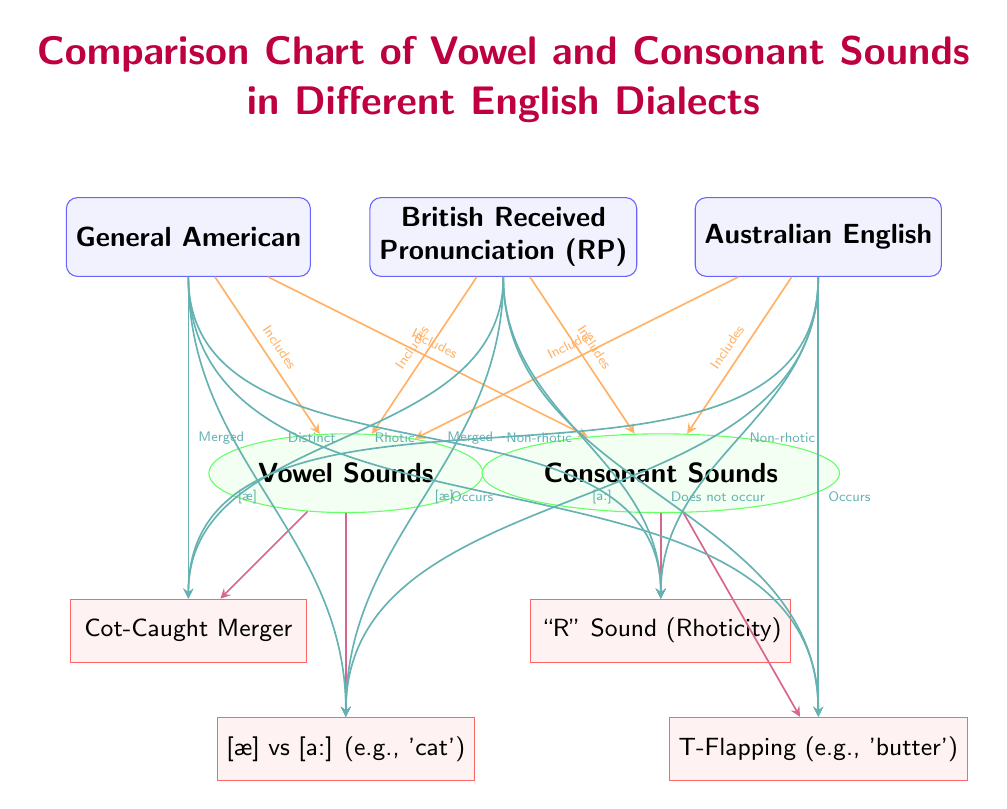What dialects are compared in the chart? The chart compares three dialects: General American, British Received Pronunciation (RP), and Australian English. These are the main nodes that represent the different dialects, making it easy to identify them at the top of the diagram.
Answer: General American, British Received Pronunciation, Australian English How many categories of sounds are included in the chart? The chart differentiates sounds into two main categories: Vowel Sounds and Consonant Sounds. This distinction is evident from the two category nodes positioned below the dialects.
Answer: 2 Which dialect shows a distinct Cot-Caught Merger? The British Received Pronunciation (RP) dialect is indicated to have a distinct Cot-Caught Merger, highlighted in the feature connections where the edge leads from RP to the Cot-Caught Merger feature.
Answer: British Received Pronunciation What does "Rhotic" refer to in the context of the General American dialect? In the context of the General American dialect, "Rhotic" refers to the pronunciation of the "R" sound, which is explicitly noted in the connection from General American to the "R" Sound feature, indicating that this dialect retains the "R" sound at the end of words.
Answer: Rhotic In the Australian English dialect, what pronunciation is indicated for 'cat'? The Australian English dialect is indicated to pronounce 'cat' as [a:], as depicted in the connection from AE to the 'cat' feature. This particular detail highlights how Australian English differs from the other dialects in the pronunciation of this word.
Answer: [a:] 